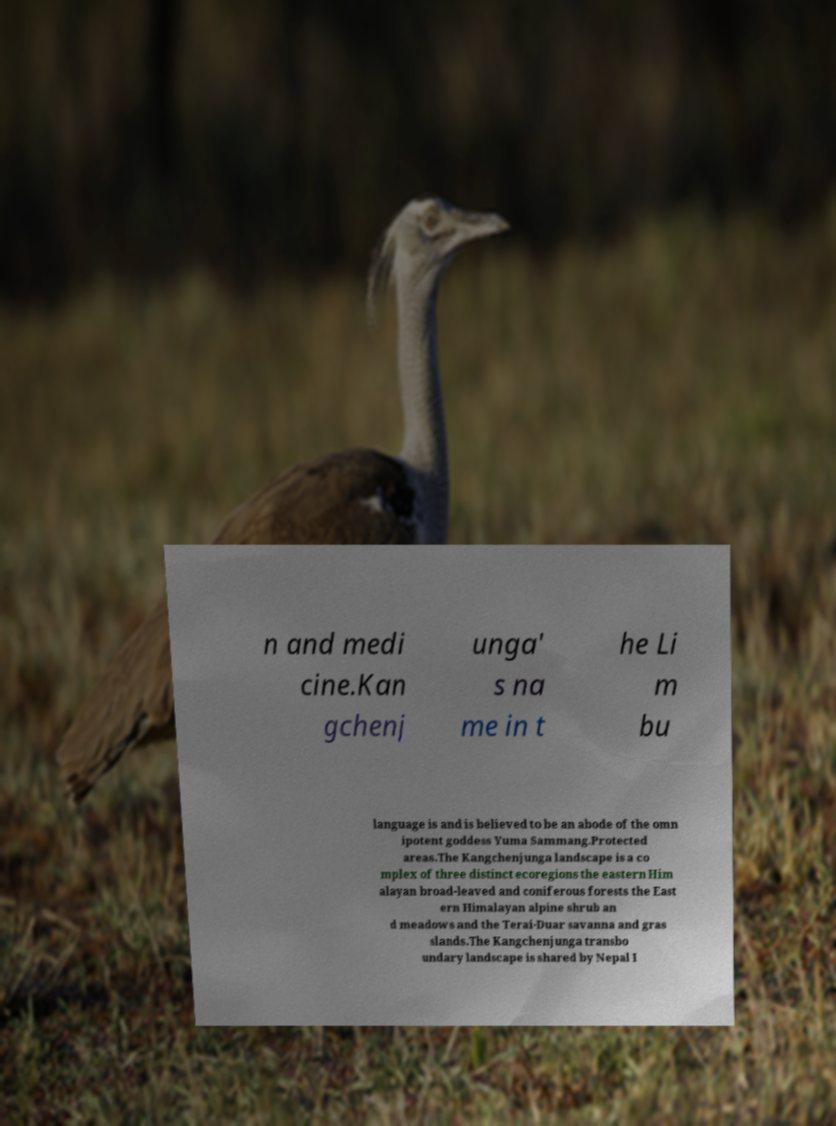There's text embedded in this image that I need extracted. Can you transcribe it verbatim? n and medi cine.Kan gchenj unga' s na me in t he Li m bu language is and is believed to be an abode of the omn ipotent goddess Yuma Sammang.Protected areas.The Kangchenjunga landscape is a co mplex of three distinct ecoregions the eastern Him alayan broad-leaved and coniferous forests the East ern Himalayan alpine shrub an d meadows and the Terai-Duar savanna and gras slands.The Kangchenjunga transbo undary landscape is shared by Nepal I 